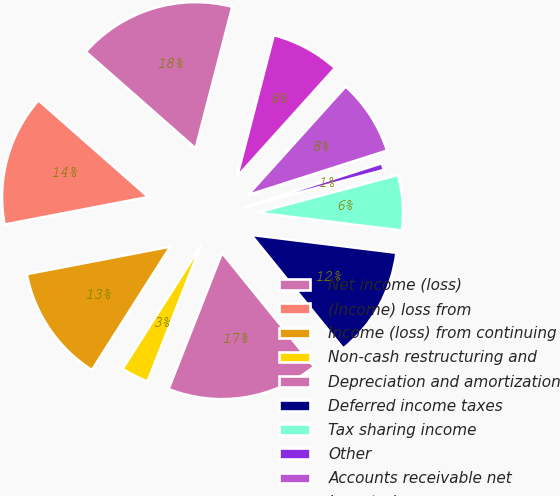<chart> <loc_0><loc_0><loc_500><loc_500><pie_chart><fcel>Net income (loss)<fcel>(Income) loss from<fcel>Income (loss) from continuing<fcel>Non-cash restructuring and<fcel>Depreciation and amortization<fcel>Deferred income taxes<fcel>Tax sharing income<fcel>Other<fcel>Accounts receivable net<fcel>Inventories<nl><fcel>17.55%<fcel>14.5%<fcel>12.97%<fcel>3.06%<fcel>16.79%<fcel>12.21%<fcel>6.11%<fcel>0.77%<fcel>8.4%<fcel>7.64%<nl></chart> 